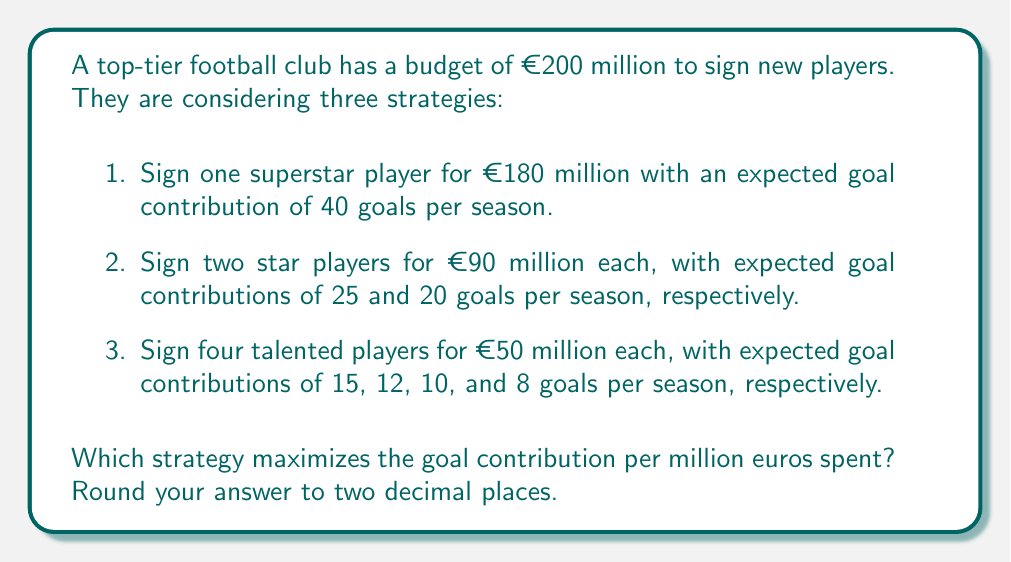Help me with this question. To determine the most cost-effective strategy, we need to calculate the goal contribution per million euros for each option:

1. Superstar player:
   Goal contribution per million = $\frac{40 \text{ goals}}{180 \text{ million euros}} = 0.2222$ goals/million

2. Two star players:
   Total goal contribution = 25 + 20 = 45 goals
   Goal contribution per million = $\frac{45 \text{ goals}}{180 \text{ million euros}} = 0.2500$ goals/million

3. Four talented players:
   Total goal contribution = 15 + 12 + 10 + 8 = 45 goals
   Goal contribution per million = $\frac{45 \text{ goals}}{200 \text{ million euros}} = 0.2250$ goals/million

Comparing the results:
Option 1: 0.2222 goals/million
Option 2: 0.2500 goals/million
Option 3: 0.2250 goals/million

The strategy that maximizes the goal contribution per million euros spent is Option 2, signing two star players.
Answer: 0.25 goals per million euros 